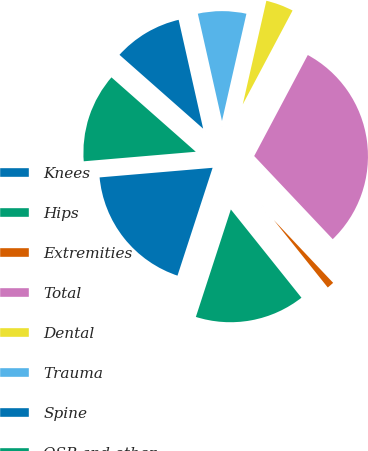Convert chart to OTSL. <chart><loc_0><loc_0><loc_500><loc_500><pie_chart><fcel>Knees<fcel>Hips<fcel>Extremities<fcel>Total<fcel>Dental<fcel>Trauma<fcel>Spine<fcel>OSP and other<nl><fcel>18.64%<fcel>15.75%<fcel>1.31%<fcel>30.19%<fcel>4.2%<fcel>7.09%<fcel>9.97%<fcel>12.86%<nl></chart> 